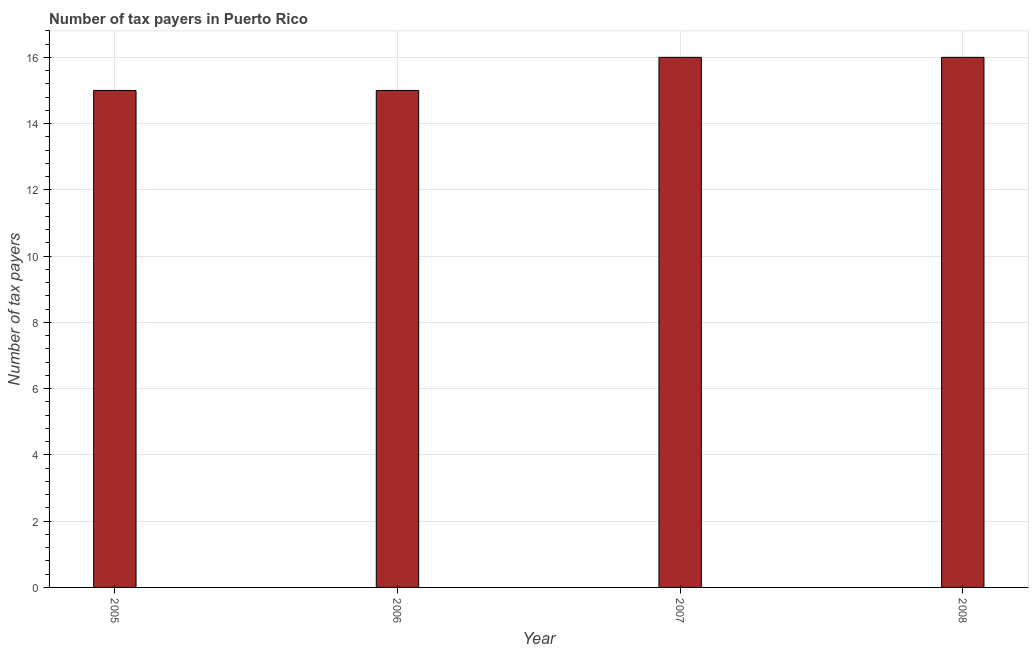Does the graph contain any zero values?
Provide a short and direct response. No. What is the title of the graph?
Provide a succinct answer. Number of tax payers in Puerto Rico. What is the label or title of the Y-axis?
Your response must be concise. Number of tax payers. What is the number of tax payers in 2008?
Offer a very short reply. 16. In which year was the number of tax payers maximum?
Give a very brief answer. 2007. What is the sum of the number of tax payers?
Your response must be concise. 62. What is the average number of tax payers per year?
Offer a terse response. 15. In how many years, is the number of tax payers greater than 13.6 ?
Keep it short and to the point. 4. What is the ratio of the number of tax payers in 2006 to that in 2007?
Keep it short and to the point. 0.94. In how many years, is the number of tax payers greater than the average number of tax payers taken over all years?
Provide a short and direct response. 2. How many bars are there?
Provide a short and direct response. 4. How many years are there in the graph?
Make the answer very short. 4. What is the difference between two consecutive major ticks on the Y-axis?
Offer a very short reply. 2. What is the Number of tax payers of 2006?
Ensure brevity in your answer.  15. What is the Number of tax payers in 2008?
Provide a short and direct response. 16. What is the difference between the Number of tax payers in 2006 and 2008?
Make the answer very short. -1. What is the difference between the Number of tax payers in 2007 and 2008?
Your answer should be compact. 0. What is the ratio of the Number of tax payers in 2005 to that in 2007?
Keep it short and to the point. 0.94. What is the ratio of the Number of tax payers in 2005 to that in 2008?
Your response must be concise. 0.94. What is the ratio of the Number of tax payers in 2006 to that in 2007?
Give a very brief answer. 0.94. What is the ratio of the Number of tax payers in 2006 to that in 2008?
Keep it short and to the point. 0.94. 